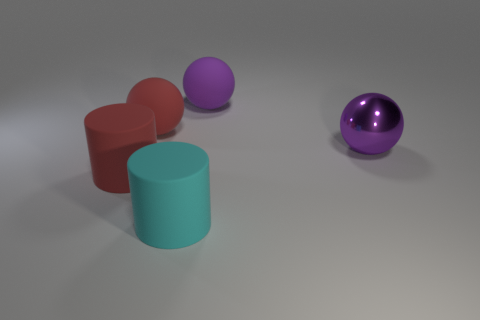Subtract all green cylinders. Subtract all blue spheres. How many cylinders are left? 2 Add 5 red spheres. How many objects exist? 10 Subtract all spheres. How many objects are left? 2 Add 5 big green things. How many big green things exist? 5 Subtract 0 purple cubes. How many objects are left? 5 Subtract all purple rubber spheres. Subtract all large balls. How many objects are left? 1 Add 3 matte things. How many matte things are left? 7 